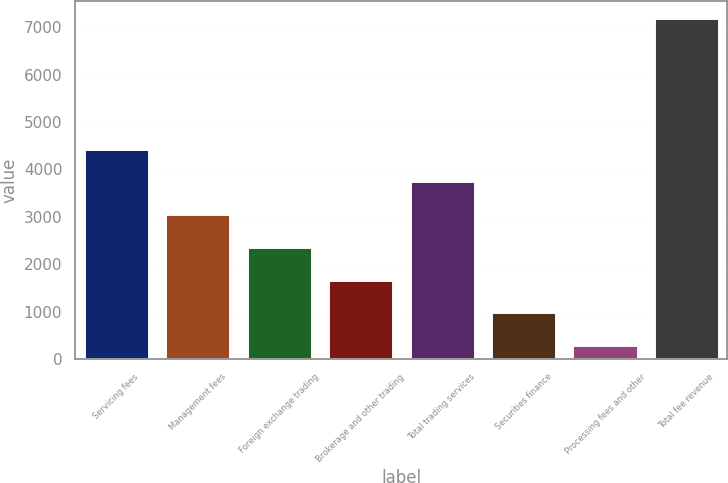Convert chart to OTSL. <chart><loc_0><loc_0><loc_500><loc_500><bar_chart><fcel>Servicing fees<fcel>Management fees<fcel>Foreign exchange trading<fcel>Brokerage and other trading<fcel>Total trading services<fcel>Securities finance<fcel>Processing fees and other<fcel>Total fee revenue<nl><fcel>4435.2<fcel>3055.8<fcel>2366.1<fcel>1676.4<fcel>3745.5<fcel>986.7<fcel>297<fcel>7194<nl></chart> 